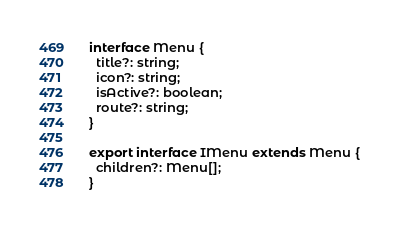<code> <loc_0><loc_0><loc_500><loc_500><_TypeScript_>interface Menu {
  title?: string;
  icon?: string;
  isActive?: boolean;
  route?: string;
}

export interface IMenu extends Menu {
  children?: Menu[];
}
</code> 